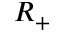<formula> <loc_0><loc_0><loc_500><loc_500>R _ { + }</formula> 